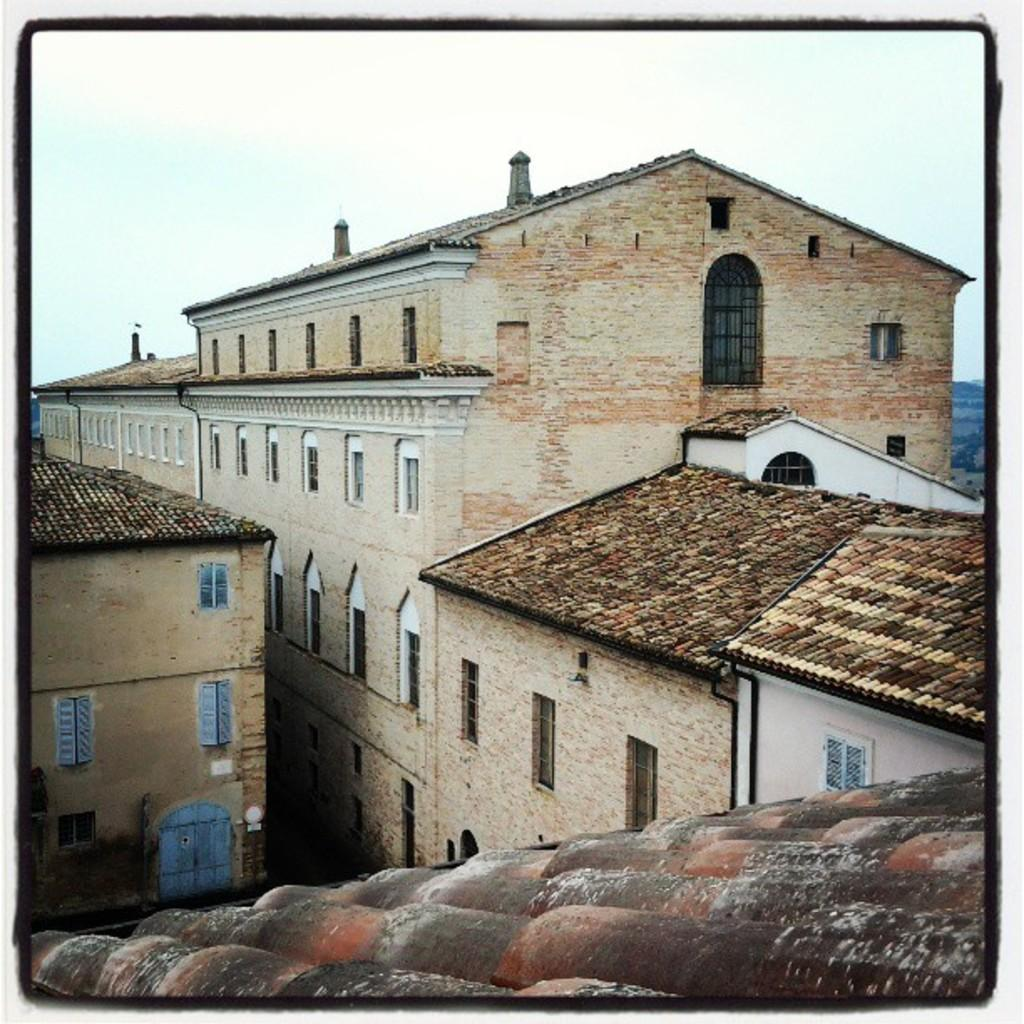What type of structures can be seen in the image? There are buildings in the image. How many chimneys are visible in the image? There are three chimneys in the image. What is visible at the top of the image? The sky is visible at the top of the image. What part of the buildings can be seen in the image? Roofs are visible in the image. What architectural feature is present in the buildings? Windows are present in the image. What type of needle can be seen in the image? There is no needle present in the image. Can you see any animals in the image? The image does not depict a zoo or any animals. 